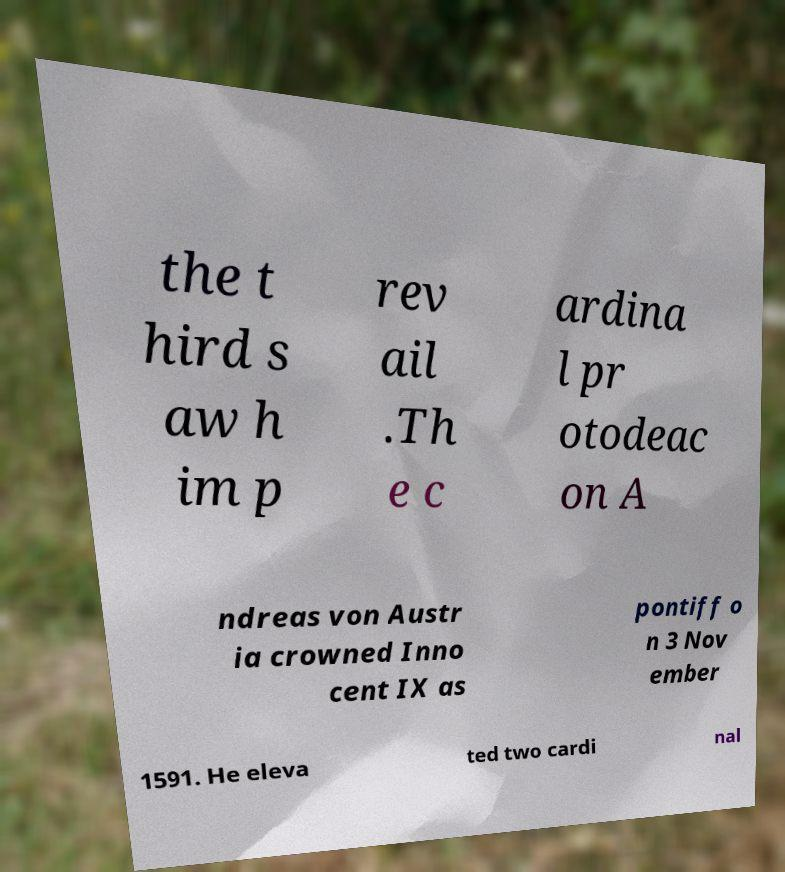Please read and relay the text visible in this image. What does it say? the t hird s aw h im p rev ail .Th e c ardina l pr otodeac on A ndreas von Austr ia crowned Inno cent IX as pontiff o n 3 Nov ember 1591. He eleva ted two cardi nal 